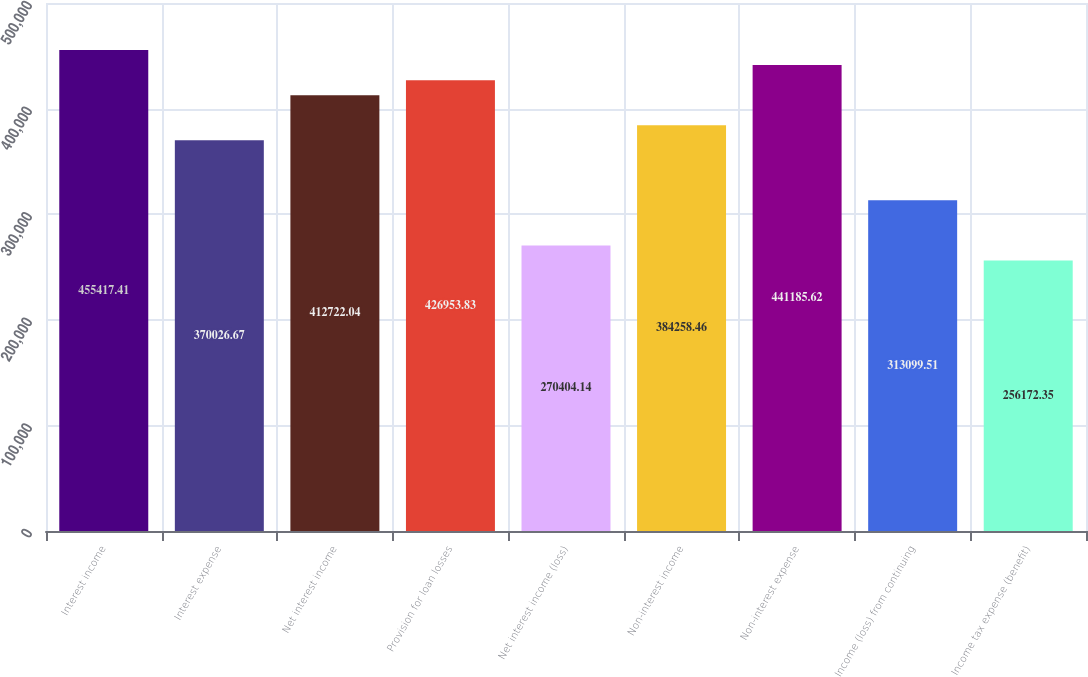<chart> <loc_0><loc_0><loc_500><loc_500><bar_chart><fcel>Interest income<fcel>Interest expense<fcel>Net interest income<fcel>Provision for loan losses<fcel>Net interest income (loss)<fcel>Non-interest income<fcel>Non-interest expense<fcel>Income (loss) from continuing<fcel>Income tax expense (benefit)<nl><fcel>455417<fcel>370027<fcel>412722<fcel>426954<fcel>270404<fcel>384258<fcel>441186<fcel>313100<fcel>256172<nl></chart> 